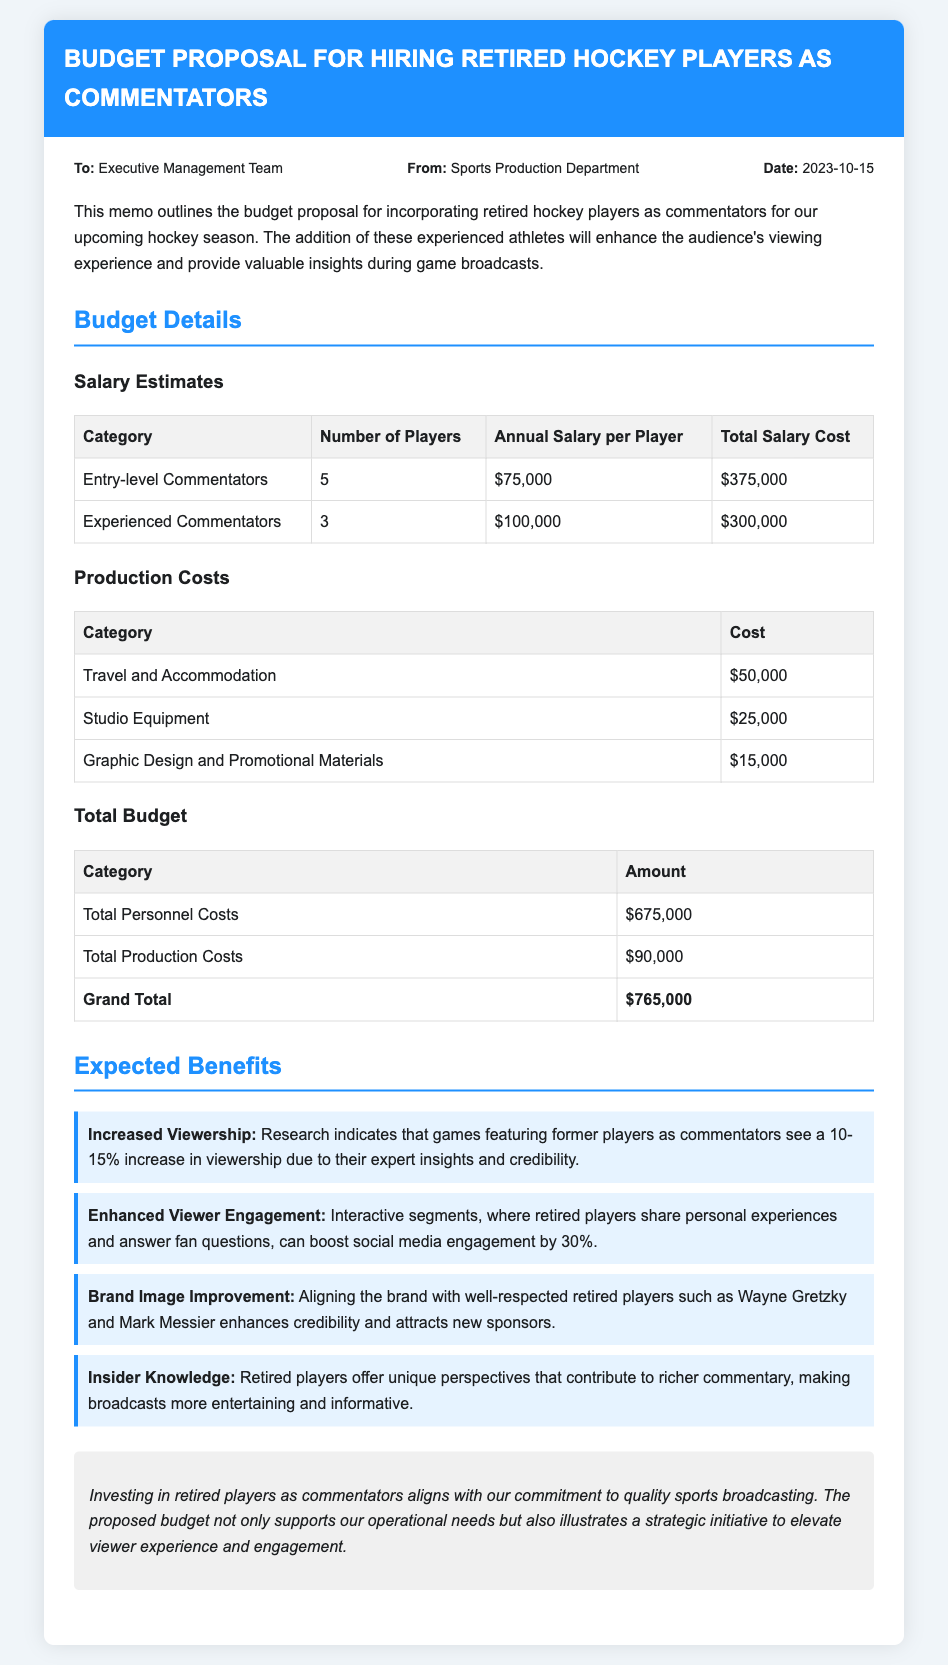what is the date of the memo? The date of the memo is mentioned in the memo details section.
Answer: 2023-10-15 how many entry-level commentators are proposed? The number of entry-level commentators is listed in the salary estimates table under the category of entry-level commentators.
Answer: 5 what is the total personnel costs? The total personnel costs are specified in the total budget section of the memo.
Answer: $675,000 what is one expected benefit of hiring retired players? Several expected benefits are listed; one can be any of them, but the first one specified in the document is used here.
Answer: Increased Viewership how much is allocated for travel and accommodation? The amount for travel and accommodation is mentioned in the production costs table.
Answer: $50,000 what is the grand total budget for the proposal? The grand total budget is the sum of total personnel costs and total production costs indicated in the budget details section.
Answer: $765,000 how many experienced commentators are proposed? The number of experienced commentators is specified in the salary estimates table under the category of experienced commentators.
Answer: 3 which department is sending the memo? The department responsible for sending the memo is indicated in the memo details section.
Answer: Sports Production Department 